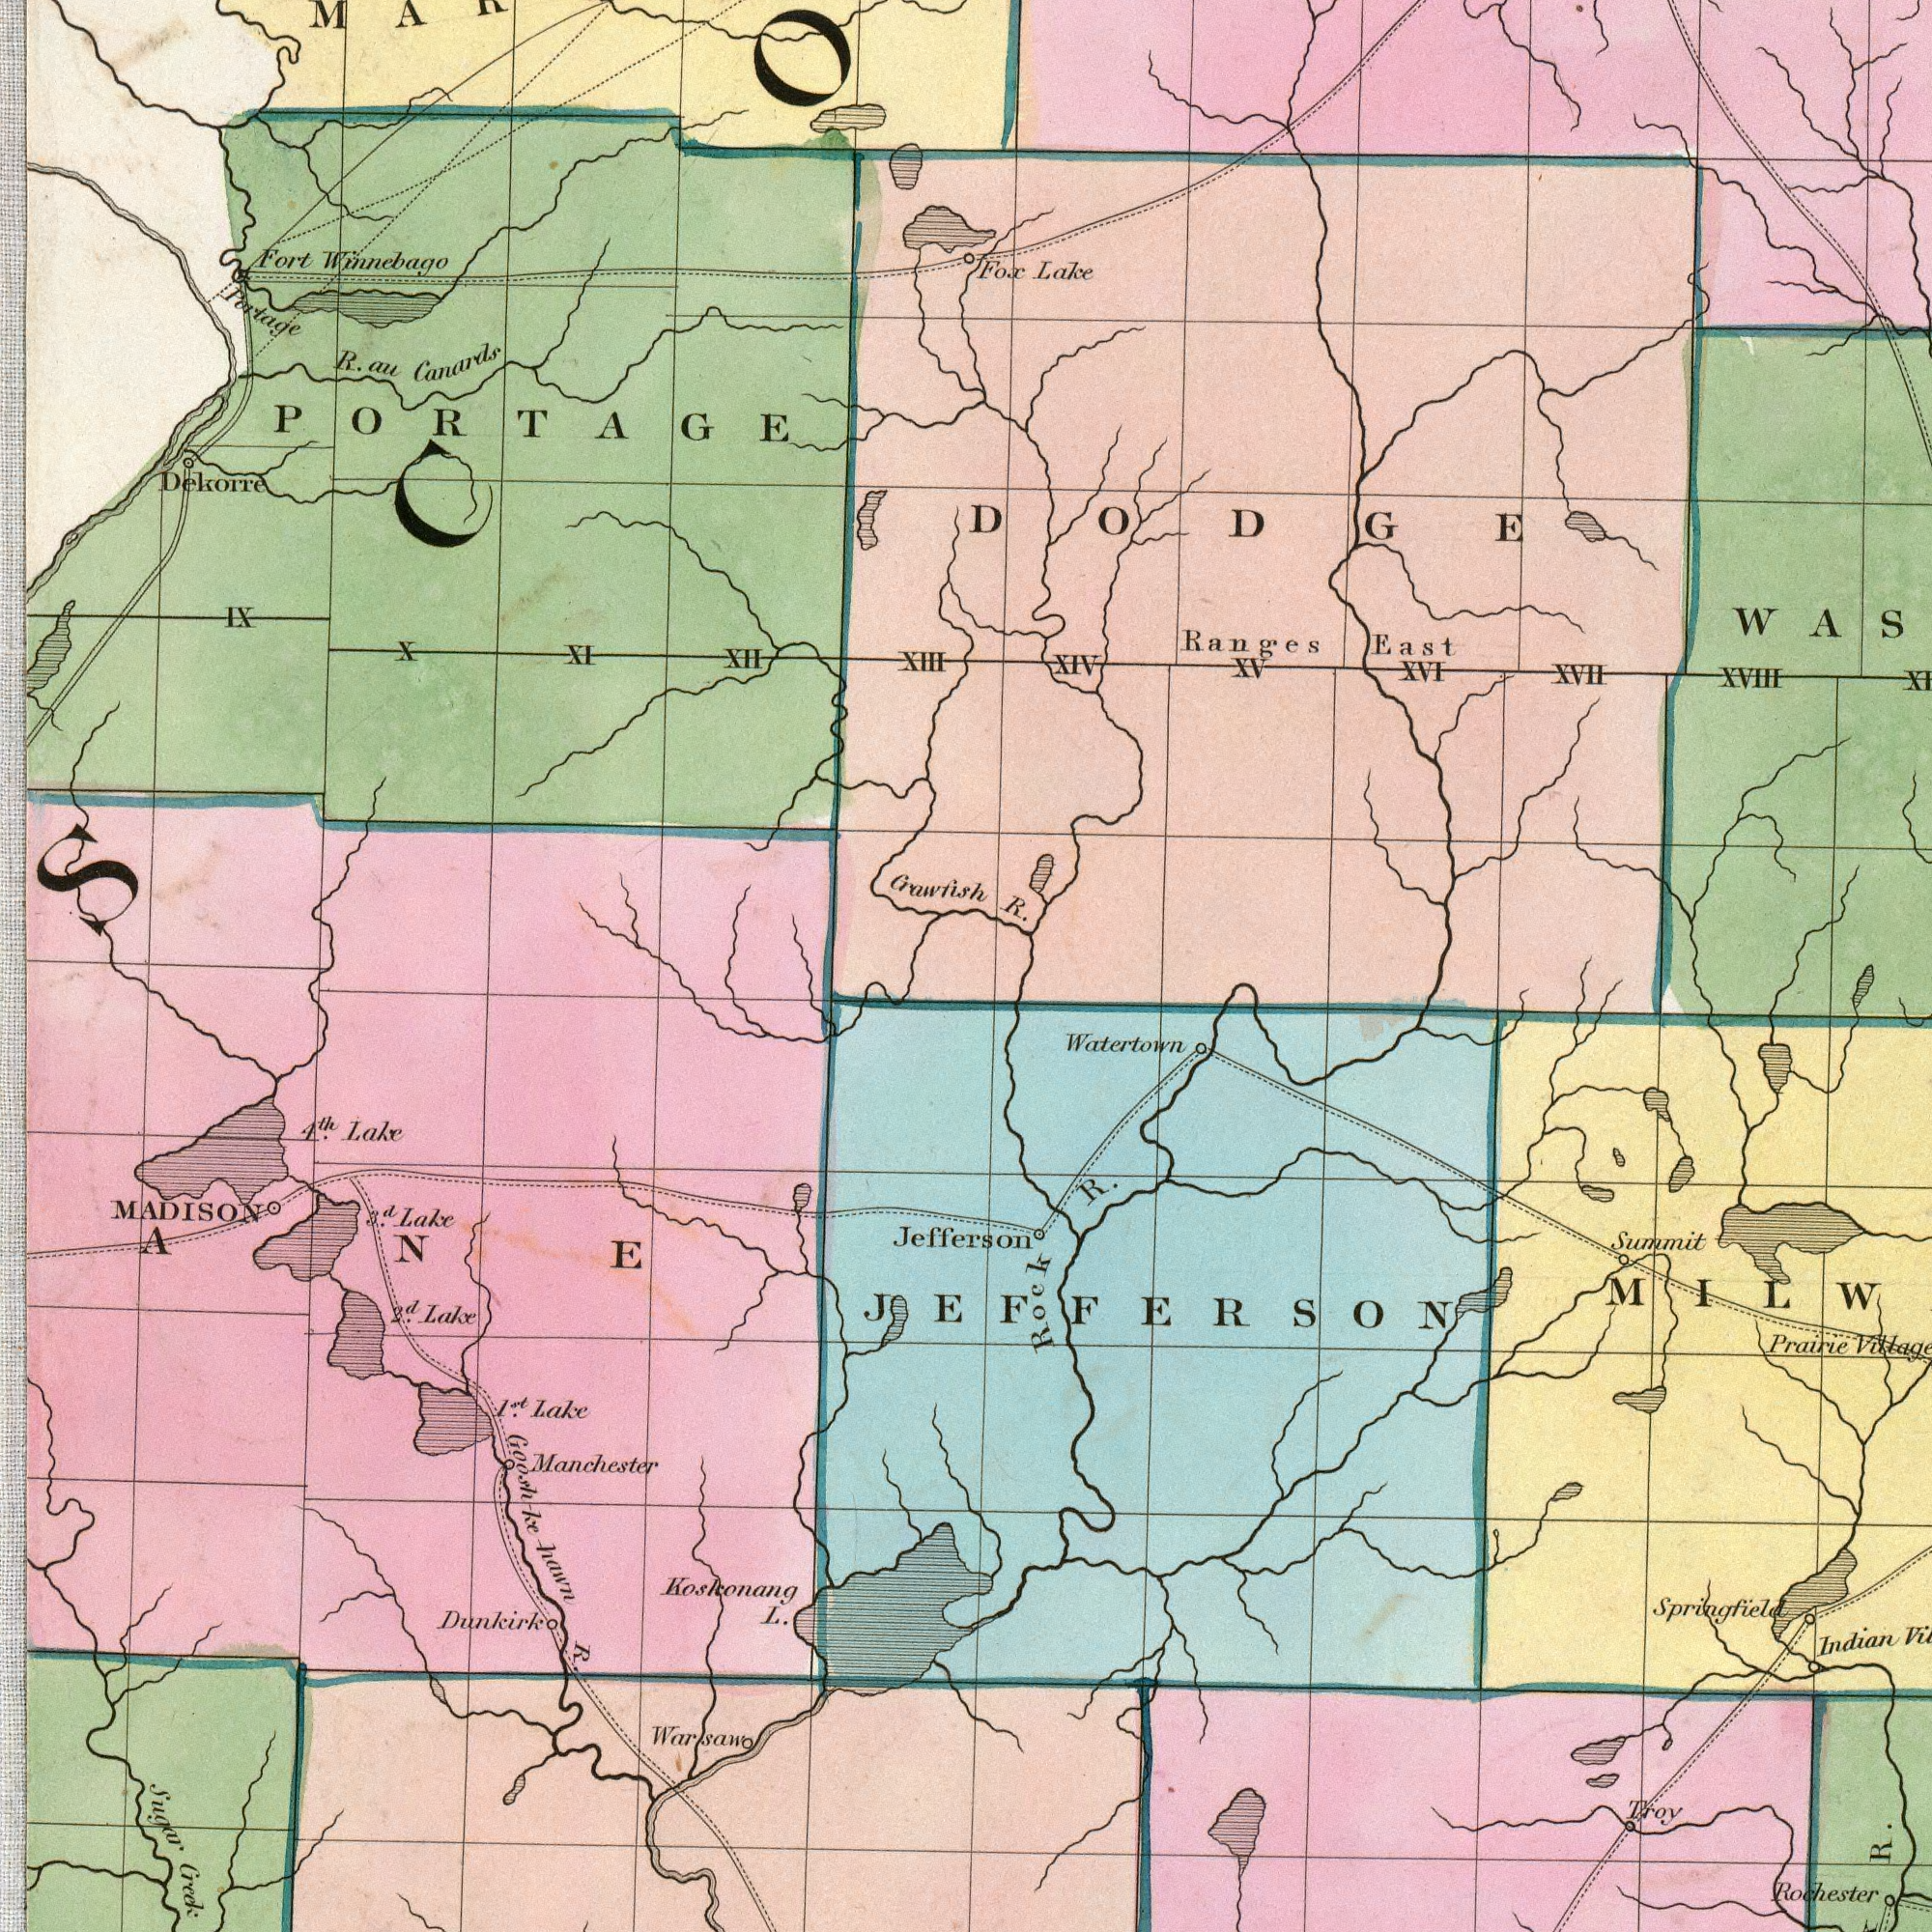What text appears in the bottom-left area of the image? MADISON Koskonang L. Manchester Sugar Creek Goosh ke hawn R. Dunkirk 2nd. Lake 1st. Lake Jefferson 3rd. Lake 4th. Lake ANE Warsaw What text is visible in the upper-left corner? Crawfish Fort Winnebago Dekorre R. au Canards Portage XIII XII X PORTAGE XI IX Fox What text appears in the bottom-right area of the image? Rock R. Rochester R. Indian Prairie Summit Troy Springfield JEFFERSON What text is visible in the upper-right corner? R. Ranges East Lake XVII XIV XVIII XVI XV Watertown DODGE 